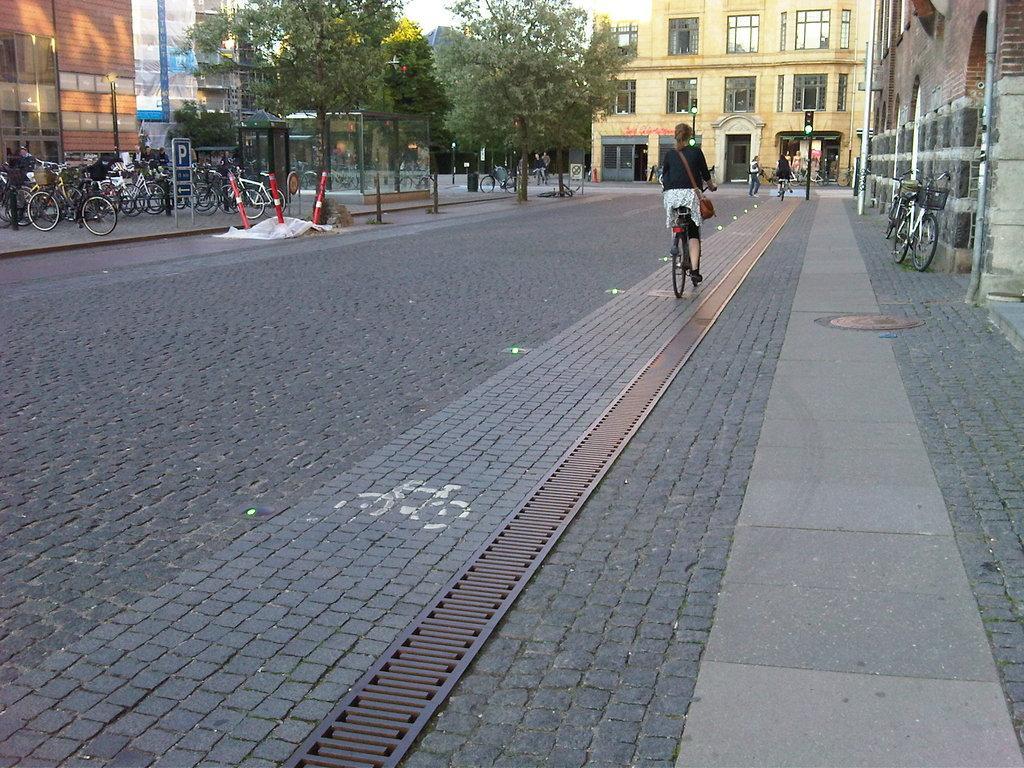Describe this image in one or two sentences. In this image there are buildings, trees and some people are sitting on cycles and riding and there are some cycles, poles and some boards. At the bottom there is a road and some grills. 